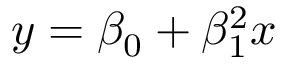<formula> <loc_0><loc_0><loc_500><loc_500>y = \beta _ { 0 } + \beta _ { 1 } ^ { 2 } x</formula> 